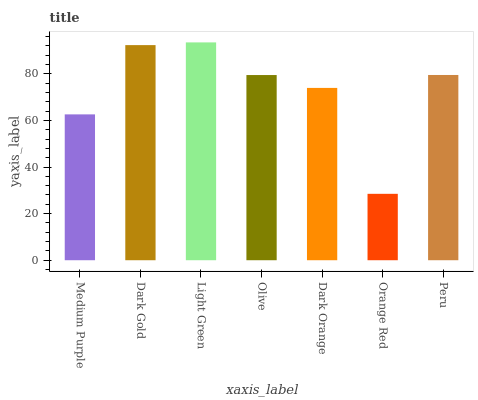Is Orange Red the minimum?
Answer yes or no. Yes. Is Light Green the maximum?
Answer yes or no. Yes. Is Dark Gold the minimum?
Answer yes or no. No. Is Dark Gold the maximum?
Answer yes or no. No. Is Dark Gold greater than Medium Purple?
Answer yes or no. Yes. Is Medium Purple less than Dark Gold?
Answer yes or no. Yes. Is Medium Purple greater than Dark Gold?
Answer yes or no. No. Is Dark Gold less than Medium Purple?
Answer yes or no. No. Is Olive the high median?
Answer yes or no. Yes. Is Olive the low median?
Answer yes or no. Yes. Is Medium Purple the high median?
Answer yes or no. No. Is Dark Gold the low median?
Answer yes or no. No. 